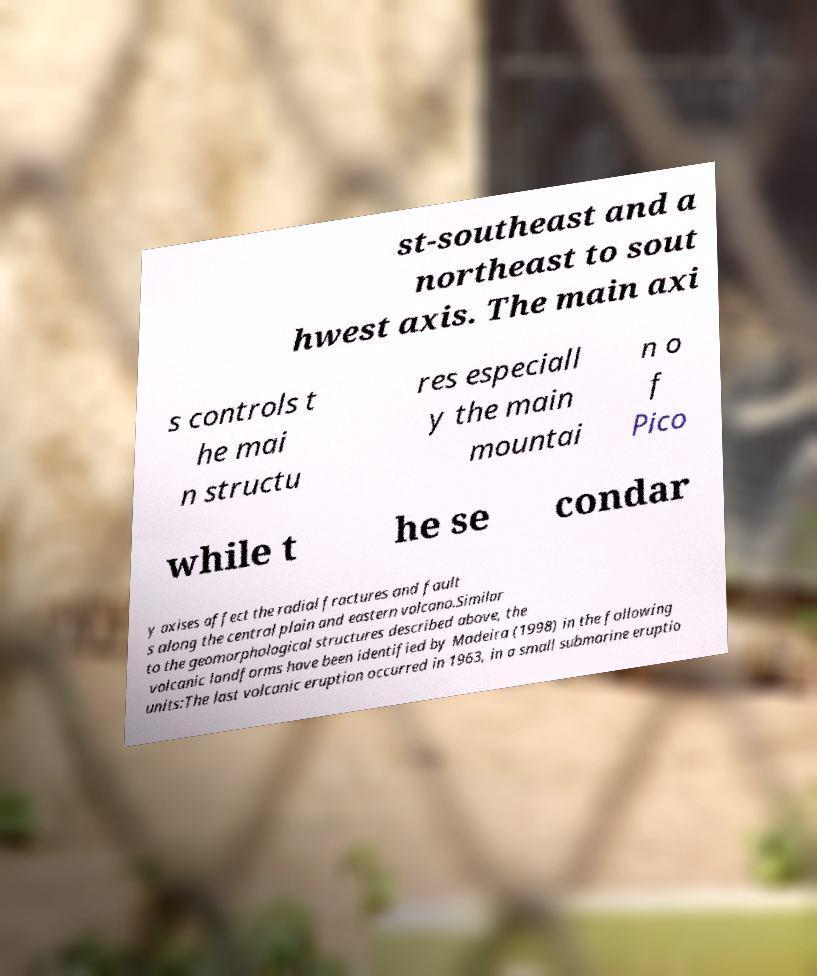Please read and relay the text visible in this image. What does it say? st-southeast and a northeast to sout hwest axis. The main axi s controls t he mai n structu res especiall y the main mountai n o f Pico while t he se condar y axises affect the radial fractures and fault s along the central plain and eastern volcano.Similar to the geomorphological structures described above, the volcanic landforms have been identified by Madeira (1998) in the following units:The last volcanic eruption occurred in 1963, in a small submarine eruptio 